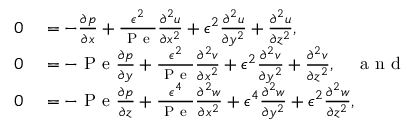<formula> <loc_0><loc_0><loc_500><loc_500>\begin{array} { r l } { 0 } & = - \frac { \partial p } { \partial x } + \frac { \epsilon ^ { 2 } } { P e } \frac { \partial ^ { 2 } u } { \partial x ^ { 2 } } + \epsilon ^ { 2 } \frac { \partial ^ { 2 } u } { \partial y ^ { 2 } } + \frac { \partial ^ { 2 } u } { \partial z ^ { 2 } } , } \\ { 0 } & = - P e \frac { \partial p } { \partial y } + \frac { \epsilon ^ { 2 } } { P e } \frac { \partial ^ { 2 } v } { \partial x ^ { 2 } } + \epsilon ^ { 2 } \frac { \partial ^ { 2 } v } { \partial y ^ { 2 } } + \frac { \partial ^ { 2 } v } { \partial z ^ { 2 } } , \quad a n d } \\ { 0 } & = - P e \frac { \partial p } { \partial z } + \frac { \epsilon ^ { 4 } } { P e } \frac { \partial ^ { 2 } w } { \partial x ^ { 2 } } + \epsilon ^ { 4 } \frac { \partial ^ { 2 } w } { \partial y ^ { 2 } } + \epsilon ^ { 2 } \frac { \partial ^ { 2 } w } { \partial z ^ { 2 } } , } \end{array}</formula> 